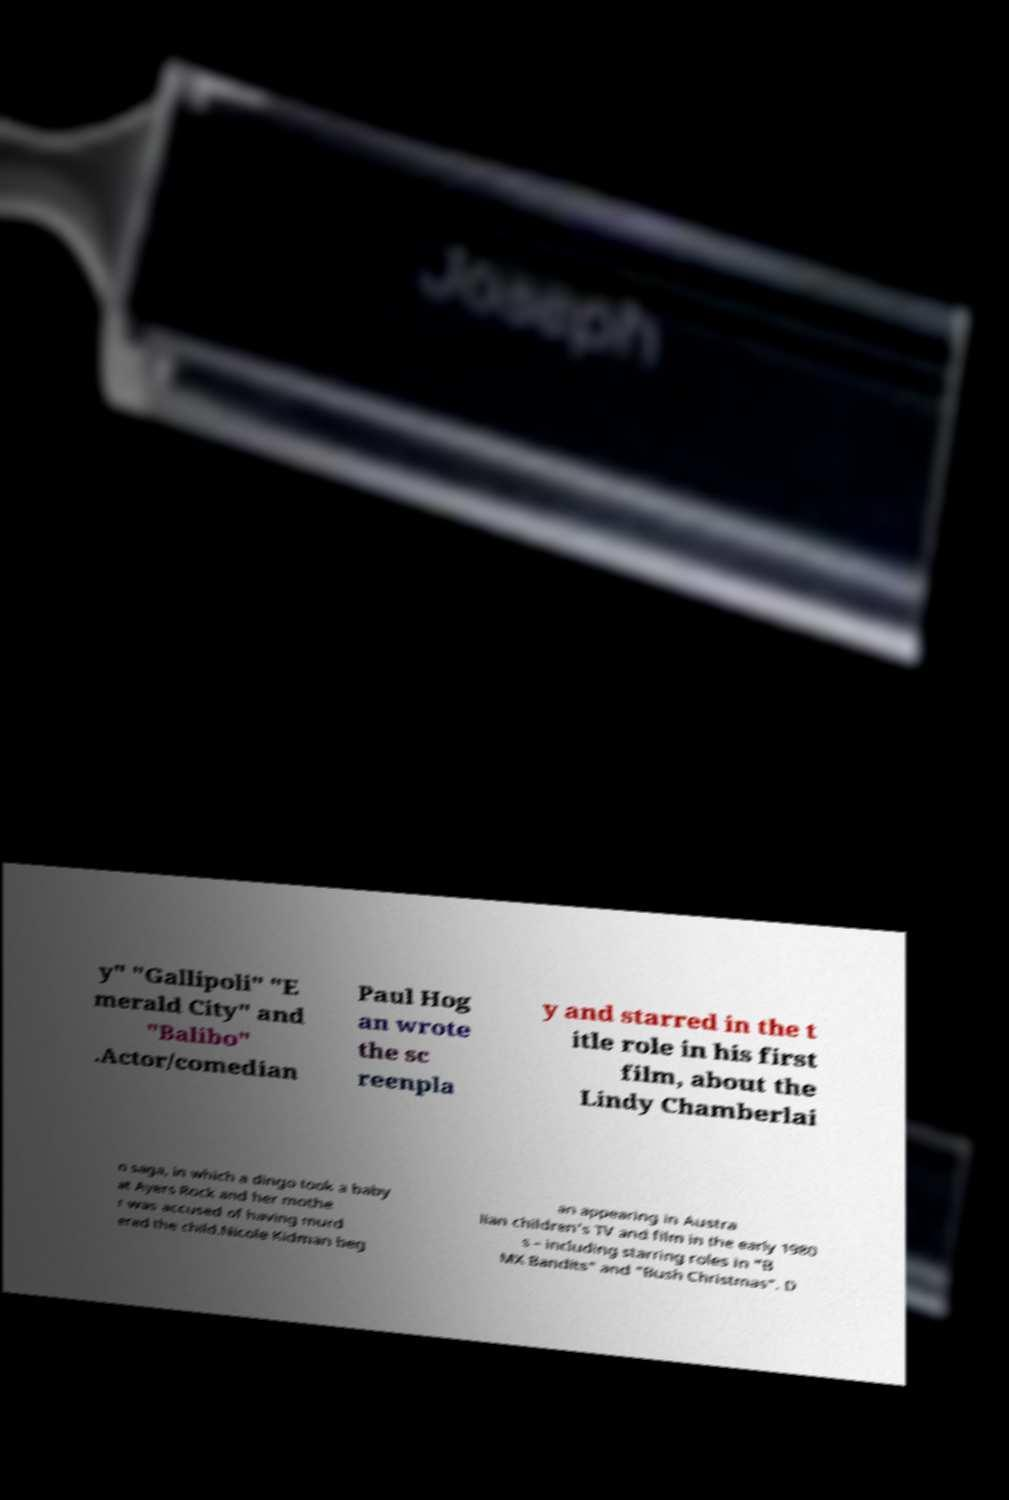Please read and relay the text visible in this image. What does it say? y" "Gallipoli" "E merald City" and "Balibo" .Actor/comedian Paul Hog an wrote the sc reenpla y and starred in the t itle role in his first film, about the Lindy Chamberlai n saga, in which a dingo took a baby at Ayers Rock and her mothe r was accused of having murd ered the child.Nicole Kidman beg an appearing in Austra lian children's TV and film in the early 1980 s – including starring roles in "B MX Bandits" and "Bush Christmas". D 